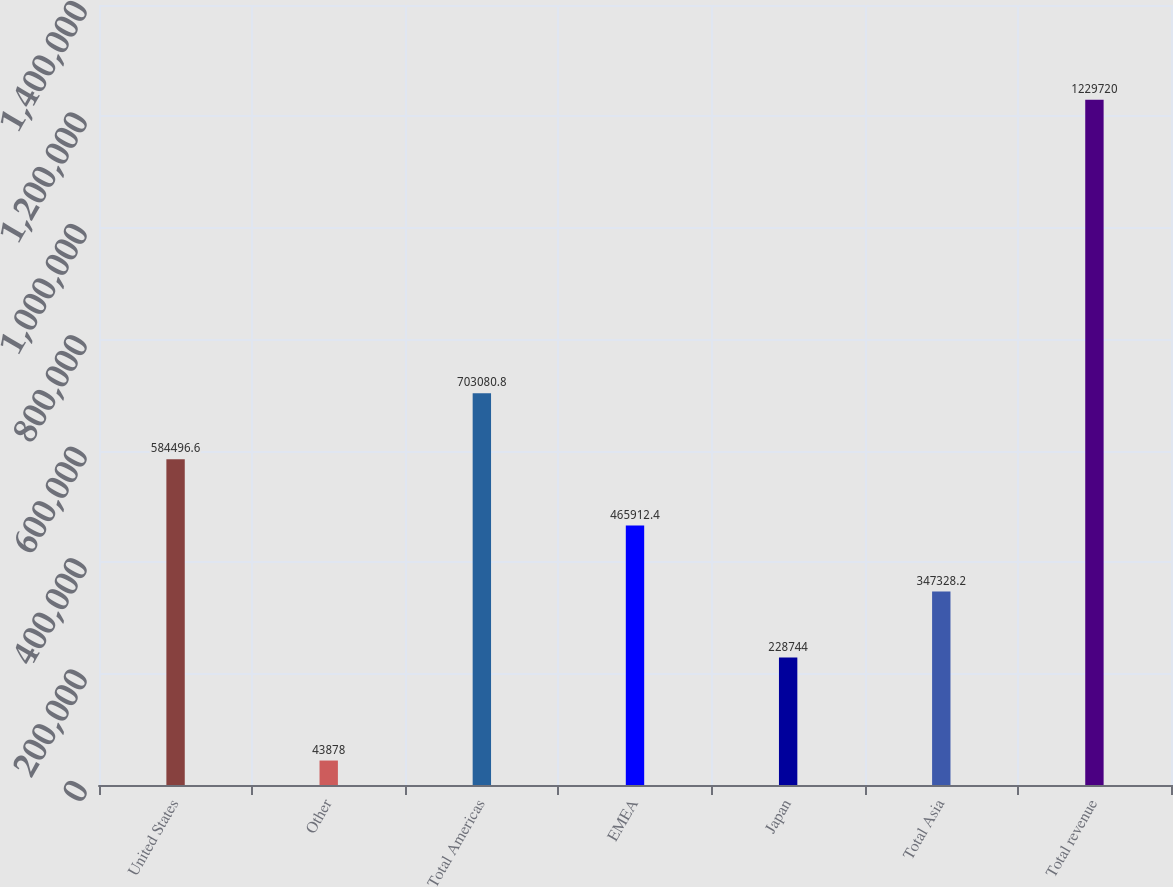<chart> <loc_0><loc_0><loc_500><loc_500><bar_chart><fcel>United States<fcel>Other<fcel>Total Americas<fcel>EMEA<fcel>Japan<fcel>Total Asia<fcel>Total revenue<nl><fcel>584497<fcel>43878<fcel>703081<fcel>465912<fcel>228744<fcel>347328<fcel>1.22972e+06<nl></chart> 